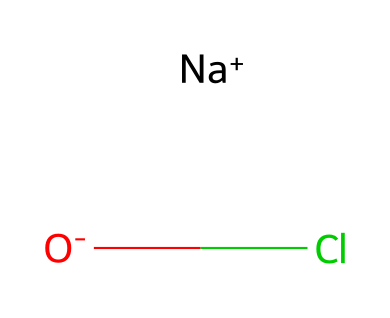What is the name of this chemical? The chemical structure represented by the SMILES notation is sodium hypochlorite, which is confirmed by identifying the sodium ion (Na+), hypochlorite ion (ClO-), and the overall structure indicative of a salt.
Answer: sodium hypochlorite How many different types of atoms are present? By analyzing the SMILES, there are three types of atoms: sodium (Na), oxygen (O), and chlorine (Cl). Each distinct atom type counts towards the total.
Answer: three What is the charge on the sodium ion? The SMILES representation indicates that sodium is represented as [Na+], meaning it carries a positive charge. Therefore, the charge can be directly identified from this notation.
Answer: positive How many total bonds are in the structure? In the hypochlorite ion, ClO- consists of one bond between chlorine and oxygen. Since sodium is not bonded directly in a covalent manner (it acts as a spectator ion), only the bond in the hypochlorite ion is counted. Thus, there is one bond total.
Answer: one Which component makes this chemical an oxidizer? The presence of the hypochlorite ion (ClO-) in sodium hypochlorite is responsible for its oxidizing properties, as it can accept electrons from other substances, a typical behavior of oxidizing agents.
Answer: hypochlorite ion What is its primary use in emergency situations? Sodium hypochlorite is primarily used for disinfection and sterilization purposes in emergency situations, particularly to sanitize water or surfaces to prevent infections in medical environments.
Answer: disinfection 